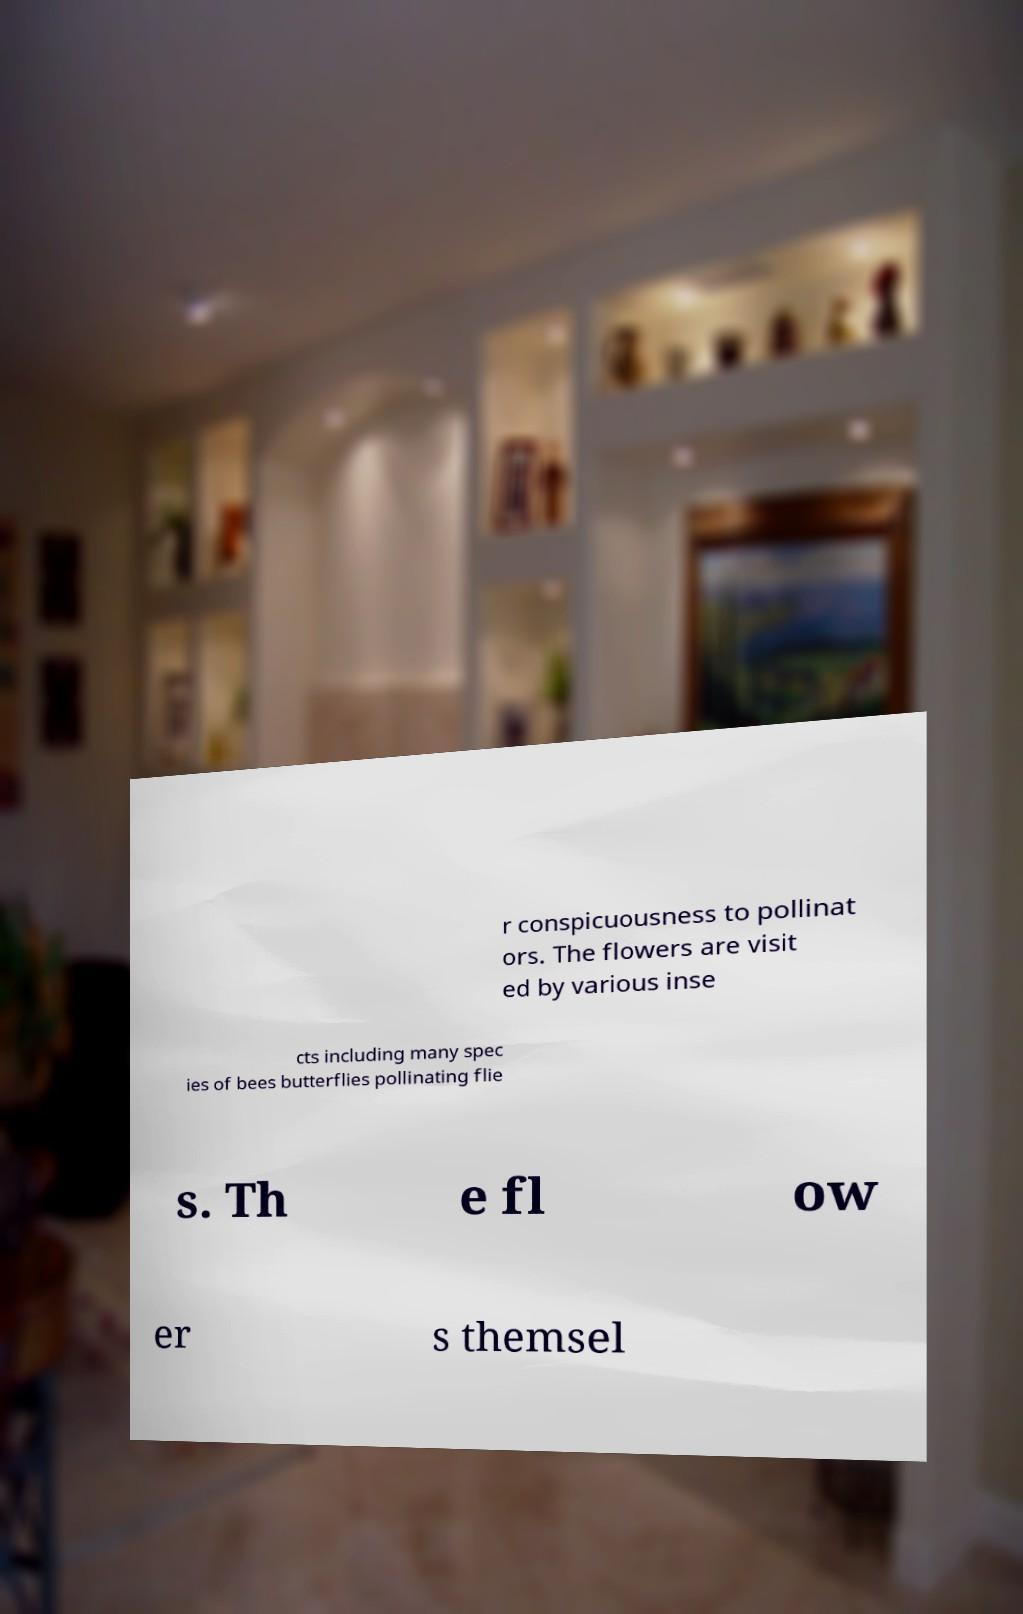I need the written content from this picture converted into text. Can you do that? r conspicuousness to pollinat ors. The flowers are visit ed by various inse cts including many spec ies of bees butterflies pollinating flie s. Th e fl ow er s themsel 